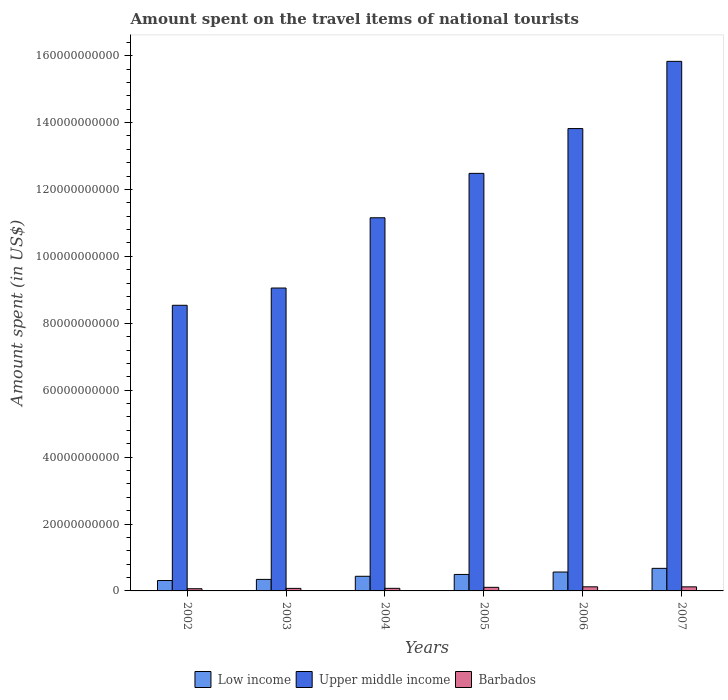How many different coloured bars are there?
Offer a very short reply. 3. Are the number of bars per tick equal to the number of legend labels?
Offer a terse response. Yes. How many bars are there on the 2nd tick from the right?
Offer a terse response. 3. In how many cases, is the number of bars for a given year not equal to the number of legend labels?
Give a very brief answer. 0. What is the amount spent on the travel items of national tourists in Upper middle income in 2005?
Keep it short and to the point. 1.25e+11. Across all years, what is the maximum amount spent on the travel items of national tourists in Upper middle income?
Provide a short and direct response. 1.58e+11. Across all years, what is the minimum amount spent on the travel items of national tourists in Upper middle income?
Your answer should be very brief. 8.54e+1. What is the total amount spent on the travel items of national tourists in Upper middle income in the graph?
Keep it short and to the point. 7.09e+11. What is the difference between the amount spent on the travel items of national tourists in Barbados in 2003 and that in 2006?
Keep it short and to the point. -4.70e+08. What is the difference between the amount spent on the travel items of national tourists in Barbados in 2003 and the amount spent on the travel items of national tourists in Low income in 2004?
Your answer should be very brief. -3.61e+09. What is the average amount spent on the travel items of national tourists in Barbados per year?
Offer a very short reply. 9.52e+08. In the year 2004, what is the difference between the amount spent on the travel items of national tourists in Barbados and amount spent on the travel items of national tourists in Upper middle income?
Your response must be concise. -1.11e+11. In how many years, is the amount spent on the travel items of national tourists in Upper middle income greater than 68000000000 US$?
Offer a terse response. 6. What is the ratio of the amount spent on the travel items of national tourists in Barbados in 2003 to that in 2007?
Keep it short and to the point. 0.62. What is the difference between the highest and the second highest amount spent on the travel items of national tourists in Barbados?
Your answer should be compact. 1.10e+07. What is the difference between the highest and the lowest amount spent on the travel items of national tourists in Low income?
Make the answer very short. 3.64e+09. Is the sum of the amount spent on the travel items of national tourists in Upper middle income in 2002 and 2004 greater than the maximum amount spent on the travel items of national tourists in Barbados across all years?
Offer a terse response. Yes. What does the 3rd bar from the left in 2005 represents?
Provide a succinct answer. Barbados. What does the 2nd bar from the right in 2002 represents?
Make the answer very short. Upper middle income. What is the difference between two consecutive major ticks on the Y-axis?
Keep it short and to the point. 2.00e+1. Does the graph contain any zero values?
Offer a terse response. No. Does the graph contain grids?
Provide a succinct answer. No. Where does the legend appear in the graph?
Give a very brief answer. Bottom center. What is the title of the graph?
Offer a terse response. Amount spent on the travel items of national tourists. What is the label or title of the Y-axis?
Give a very brief answer. Amount spent (in US$). What is the Amount spent (in US$) of Low income in 2002?
Ensure brevity in your answer.  3.11e+09. What is the Amount spent (in US$) in Upper middle income in 2002?
Provide a succinct answer. 8.54e+1. What is the Amount spent (in US$) of Barbados in 2002?
Your answer should be compact. 6.58e+08. What is the Amount spent (in US$) of Low income in 2003?
Keep it short and to the point. 3.45e+09. What is the Amount spent (in US$) in Upper middle income in 2003?
Ensure brevity in your answer.  9.05e+1. What is the Amount spent (in US$) of Barbados in 2003?
Provide a succinct answer. 7.58e+08. What is the Amount spent (in US$) in Low income in 2004?
Offer a very short reply. 4.37e+09. What is the Amount spent (in US$) in Upper middle income in 2004?
Provide a short and direct response. 1.12e+11. What is the Amount spent (in US$) of Barbados in 2004?
Offer a very short reply. 7.75e+08. What is the Amount spent (in US$) in Low income in 2005?
Your answer should be very brief. 4.93e+09. What is the Amount spent (in US$) of Upper middle income in 2005?
Ensure brevity in your answer.  1.25e+11. What is the Amount spent (in US$) in Barbados in 2005?
Your response must be concise. 1.07e+09. What is the Amount spent (in US$) in Low income in 2006?
Your response must be concise. 5.65e+09. What is the Amount spent (in US$) of Upper middle income in 2006?
Ensure brevity in your answer.  1.38e+11. What is the Amount spent (in US$) of Barbados in 2006?
Provide a succinct answer. 1.23e+09. What is the Amount spent (in US$) of Low income in 2007?
Give a very brief answer. 6.75e+09. What is the Amount spent (in US$) in Upper middle income in 2007?
Provide a short and direct response. 1.58e+11. What is the Amount spent (in US$) in Barbados in 2007?
Offer a very short reply. 1.22e+09. Across all years, what is the maximum Amount spent (in US$) in Low income?
Provide a short and direct response. 6.75e+09. Across all years, what is the maximum Amount spent (in US$) of Upper middle income?
Offer a very short reply. 1.58e+11. Across all years, what is the maximum Amount spent (in US$) of Barbados?
Keep it short and to the point. 1.23e+09. Across all years, what is the minimum Amount spent (in US$) in Low income?
Your response must be concise. 3.11e+09. Across all years, what is the minimum Amount spent (in US$) of Upper middle income?
Your response must be concise. 8.54e+1. Across all years, what is the minimum Amount spent (in US$) of Barbados?
Provide a succinct answer. 6.58e+08. What is the total Amount spent (in US$) of Low income in the graph?
Keep it short and to the point. 2.82e+1. What is the total Amount spent (in US$) in Upper middle income in the graph?
Your answer should be very brief. 7.09e+11. What is the total Amount spent (in US$) of Barbados in the graph?
Your answer should be compact. 5.71e+09. What is the difference between the Amount spent (in US$) of Low income in 2002 and that in 2003?
Your response must be concise. -3.36e+08. What is the difference between the Amount spent (in US$) of Upper middle income in 2002 and that in 2003?
Make the answer very short. -5.16e+09. What is the difference between the Amount spent (in US$) in Barbados in 2002 and that in 2003?
Give a very brief answer. -1.00e+08. What is the difference between the Amount spent (in US$) in Low income in 2002 and that in 2004?
Give a very brief answer. -1.26e+09. What is the difference between the Amount spent (in US$) of Upper middle income in 2002 and that in 2004?
Provide a short and direct response. -2.62e+1. What is the difference between the Amount spent (in US$) of Barbados in 2002 and that in 2004?
Offer a terse response. -1.17e+08. What is the difference between the Amount spent (in US$) of Low income in 2002 and that in 2005?
Provide a short and direct response. -1.82e+09. What is the difference between the Amount spent (in US$) of Upper middle income in 2002 and that in 2005?
Provide a short and direct response. -3.94e+1. What is the difference between the Amount spent (in US$) of Barbados in 2002 and that in 2005?
Give a very brief answer. -4.15e+08. What is the difference between the Amount spent (in US$) of Low income in 2002 and that in 2006?
Offer a very short reply. -2.54e+09. What is the difference between the Amount spent (in US$) in Upper middle income in 2002 and that in 2006?
Provide a succinct answer. -5.28e+1. What is the difference between the Amount spent (in US$) of Barbados in 2002 and that in 2006?
Make the answer very short. -5.70e+08. What is the difference between the Amount spent (in US$) in Low income in 2002 and that in 2007?
Your response must be concise. -3.64e+09. What is the difference between the Amount spent (in US$) of Upper middle income in 2002 and that in 2007?
Give a very brief answer. -7.29e+1. What is the difference between the Amount spent (in US$) of Barbados in 2002 and that in 2007?
Your answer should be very brief. -5.59e+08. What is the difference between the Amount spent (in US$) in Low income in 2003 and that in 2004?
Provide a succinct answer. -9.27e+08. What is the difference between the Amount spent (in US$) of Upper middle income in 2003 and that in 2004?
Make the answer very short. -2.10e+1. What is the difference between the Amount spent (in US$) in Barbados in 2003 and that in 2004?
Make the answer very short. -1.70e+07. What is the difference between the Amount spent (in US$) in Low income in 2003 and that in 2005?
Your answer should be compact. -1.48e+09. What is the difference between the Amount spent (in US$) in Upper middle income in 2003 and that in 2005?
Give a very brief answer. -3.43e+1. What is the difference between the Amount spent (in US$) of Barbados in 2003 and that in 2005?
Ensure brevity in your answer.  -3.15e+08. What is the difference between the Amount spent (in US$) in Low income in 2003 and that in 2006?
Your answer should be compact. -2.20e+09. What is the difference between the Amount spent (in US$) in Upper middle income in 2003 and that in 2006?
Provide a succinct answer. -4.77e+1. What is the difference between the Amount spent (in US$) of Barbados in 2003 and that in 2006?
Provide a succinct answer. -4.70e+08. What is the difference between the Amount spent (in US$) of Low income in 2003 and that in 2007?
Give a very brief answer. -3.30e+09. What is the difference between the Amount spent (in US$) in Upper middle income in 2003 and that in 2007?
Your answer should be compact. -6.78e+1. What is the difference between the Amount spent (in US$) in Barbados in 2003 and that in 2007?
Provide a short and direct response. -4.59e+08. What is the difference between the Amount spent (in US$) of Low income in 2004 and that in 2005?
Your answer should be very brief. -5.53e+08. What is the difference between the Amount spent (in US$) of Upper middle income in 2004 and that in 2005?
Make the answer very short. -1.33e+1. What is the difference between the Amount spent (in US$) of Barbados in 2004 and that in 2005?
Give a very brief answer. -2.98e+08. What is the difference between the Amount spent (in US$) of Low income in 2004 and that in 2006?
Keep it short and to the point. -1.28e+09. What is the difference between the Amount spent (in US$) in Upper middle income in 2004 and that in 2006?
Offer a terse response. -2.67e+1. What is the difference between the Amount spent (in US$) in Barbados in 2004 and that in 2006?
Keep it short and to the point. -4.53e+08. What is the difference between the Amount spent (in US$) of Low income in 2004 and that in 2007?
Provide a short and direct response. -2.37e+09. What is the difference between the Amount spent (in US$) of Upper middle income in 2004 and that in 2007?
Give a very brief answer. -4.68e+1. What is the difference between the Amount spent (in US$) in Barbados in 2004 and that in 2007?
Offer a very short reply. -4.42e+08. What is the difference between the Amount spent (in US$) of Low income in 2005 and that in 2006?
Give a very brief answer. -7.22e+08. What is the difference between the Amount spent (in US$) of Upper middle income in 2005 and that in 2006?
Keep it short and to the point. -1.34e+1. What is the difference between the Amount spent (in US$) in Barbados in 2005 and that in 2006?
Keep it short and to the point. -1.55e+08. What is the difference between the Amount spent (in US$) of Low income in 2005 and that in 2007?
Give a very brief answer. -1.82e+09. What is the difference between the Amount spent (in US$) of Upper middle income in 2005 and that in 2007?
Ensure brevity in your answer.  -3.35e+1. What is the difference between the Amount spent (in US$) of Barbados in 2005 and that in 2007?
Offer a terse response. -1.44e+08. What is the difference between the Amount spent (in US$) in Low income in 2006 and that in 2007?
Make the answer very short. -1.10e+09. What is the difference between the Amount spent (in US$) of Upper middle income in 2006 and that in 2007?
Give a very brief answer. -2.01e+1. What is the difference between the Amount spent (in US$) in Barbados in 2006 and that in 2007?
Make the answer very short. 1.10e+07. What is the difference between the Amount spent (in US$) in Low income in 2002 and the Amount spent (in US$) in Upper middle income in 2003?
Ensure brevity in your answer.  -8.74e+1. What is the difference between the Amount spent (in US$) of Low income in 2002 and the Amount spent (in US$) of Barbados in 2003?
Provide a succinct answer. 2.35e+09. What is the difference between the Amount spent (in US$) in Upper middle income in 2002 and the Amount spent (in US$) in Barbados in 2003?
Give a very brief answer. 8.46e+1. What is the difference between the Amount spent (in US$) in Low income in 2002 and the Amount spent (in US$) in Upper middle income in 2004?
Your answer should be very brief. -1.08e+11. What is the difference between the Amount spent (in US$) in Low income in 2002 and the Amount spent (in US$) in Barbados in 2004?
Your answer should be compact. 2.33e+09. What is the difference between the Amount spent (in US$) of Upper middle income in 2002 and the Amount spent (in US$) of Barbados in 2004?
Keep it short and to the point. 8.46e+1. What is the difference between the Amount spent (in US$) in Low income in 2002 and the Amount spent (in US$) in Upper middle income in 2005?
Ensure brevity in your answer.  -1.22e+11. What is the difference between the Amount spent (in US$) in Low income in 2002 and the Amount spent (in US$) in Barbados in 2005?
Keep it short and to the point. 2.04e+09. What is the difference between the Amount spent (in US$) of Upper middle income in 2002 and the Amount spent (in US$) of Barbados in 2005?
Offer a very short reply. 8.43e+1. What is the difference between the Amount spent (in US$) in Low income in 2002 and the Amount spent (in US$) in Upper middle income in 2006?
Ensure brevity in your answer.  -1.35e+11. What is the difference between the Amount spent (in US$) in Low income in 2002 and the Amount spent (in US$) in Barbados in 2006?
Provide a succinct answer. 1.88e+09. What is the difference between the Amount spent (in US$) of Upper middle income in 2002 and the Amount spent (in US$) of Barbados in 2006?
Make the answer very short. 8.42e+1. What is the difference between the Amount spent (in US$) of Low income in 2002 and the Amount spent (in US$) of Upper middle income in 2007?
Keep it short and to the point. -1.55e+11. What is the difference between the Amount spent (in US$) in Low income in 2002 and the Amount spent (in US$) in Barbados in 2007?
Your response must be concise. 1.89e+09. What is the difference between the Amount spent (in US$) of Upper middle income in 2002 and the Amount spent (in US$) of Barbados in 2007?
Give a very brief answer. 8.42e+1. What is the difference between the Amount spent (in US$) of Low income in 2003 and the Amount spent (in US$) of Upper middle income in 2004?
Make the answer very short. -1.08e+11. What is the difference between the Amount spent (in US$) in Low income in 2003 and the Amount spent (in US$) in Barbados in 2004?
Ensure brevity in your answer.  2.67e+09. What is the difference between the Amount spent (in US$) of Upper middle income in 2003 and the Amount spent (in US$) of Barbados in 2004?
Make the answer very short. 8.98e+1. What is the difference between the Amount spent (in US$) of Low income in 2003 and the Amount spent (in US$) of Upper middle income in 2005?
Offer a terse response. -1.21e+11. What is the difference between the Amount spent (in US$) in Low income in 2003 and the Amount spent (in US$) in Barbados in 2005?
Offer a very short reply. 2.37e+09. What is the difference between the Amount spent (in US$) of Upper middle income in 2003 and the Amount spent (in US$) of Barbados in 2005?
Offer a terse response. 8.95e+1. What is the difference between the Amount spent (in US$) in Low income in 2003 and the Amount spent (in US$) in Upper middle income in 2006?
Your answer should be very brief. -1.35e+11. What is the difference between the Amount spent (in US$) of Low income in 2003 and the Amount spent (in US$) of Barbados in 2006?
Offer a very short reply. 2.22e+09. What is the difference between the Amount spent (in US$) of Upper middle income in 2003 and the Amount spent (in US$) of Barbados in 2006?
Keep it short and to the point. 8.93e+1. What is the difference between the Amount spent (in US$) of Low income in 2003 and the Amount spent (in US$) of Upper middle income in 2007?
Your response must be concise. -1.55e+11. What is the difference between the Amount spent (in US$) in Low income in 2003 and the Amount spent (in US$) in Barbados in 2007?
Give a very brief answer. 2.23e+09. What is the difference between the Amount spent (in US$) in Upper middle income in 2003 and the Amount spent (in US$) in Barbados in 2007?
Your answer should be very brief. 8.93e+1. What is the difference between the Amount spent (in US$) of Low income in 2004 and the Amount spent (in US$) of Upper middle income in 2005?
Offer a terse response. -1.20e+11. What is the difference between the Amount spent (in US$) of Low income in 2004 and the Amount spent (in US$) of Barbados in 2005?
Offer a terse response. 3.30e+09. What is the difference between the Amount spent (in US$) in Upper middle income in 2004 and the Amount spent (in US$) in Barbados in 2005?
Make the answer very short. 1.10e+11. What is the difference between the Amount spent (in US$) of Low income in 2004 and the Amount spent (in US$) of Upper middle income in 2006?
Provide a short and direct response. -1.34e+11. What is the difference between the Amount spent (in US$) in Low income in 2004 and the Amount spent (in US$) in Barbados in 2006?
Make the answer very short. 3.14e+09. What is the difference between the Amount spent (in US$) in Upper middle income in 2004 and the Amount spent (in US$) in Barbados in 2006?
Ensure brevity in your answer.  1.10e+11. What is the difference between the Amount spent (in US$) of Low income in 2004 and the Amount spent (in US$) of Upper middle income in 2007?
Offer a very short reply. -1.54e+11. What is the difference between the Amount spent (in US$) in Low income in 2004 and the Amount spent (in US$) in Barbados in 2007?
Keep it short and to the point. 3.16e+09. What is the difference between the Amount spent (in US$) in Upper middle income in 2004 and the Amount spent (in US$) in Barbados in 2007?
Provide a short and direct response. 1.10e+11. What is the difference between the Amount spent (in US$) in Low income in 2005 and the Amount spent (in US$) in Upper middle income in 2006?
Make the answer very short. -1.33e+11. What is the difference between the Amount spent (in US$) in Low income in 2005 and the Amount spent (in US$) in Barbados in 2006?
Offer a very short reply. 3.70e+09. What is the difference between the Amount spent (in US$) in Upper middle income in 2005 and the Amount spent (in US$) in Barbados in 2006?
Provide a succinct answer. 1.24e+11. What is the difference between the Amount spent (in US$) of Low income in 2005 and the Amount spent (in US$) of Upper middle income in 2007?
Make the answer very short. -1.53e+11. What is the difference between the Amount spent (in US$) in Low income in 2005 and the Amount spent (in US$) in Barbados in 2007?
Give a very brief answer. 3.71e+09. What is the difference between the Amount spent (in US$) of Upper middle income in 2005 and the Amount spent (in US$) of Barbados in 2007?
Provide a short and direct response. 1.24e+11. What is the difference between the Amount spent (in US$) of Low income in 2006 and the Amount spent (in US$) of Upper middle income in 2007?
Make the answer very short. -1.53e+11. What is the difference between the Amount spent (in US$) in Low income in 2006 and the Amount spent (in US$) in Barbados in 2007?
Offer a terse response. 4.43e+09. What is the difference between the Amount spent (in US$) in Upper middle income in 2006 and the Amount spent (in US$) in Barbados in 2007?
Provide a short and direct response. 1.37e+11. What is the average Amount spent (in US$) in Low income per year?
Your answer should be very brief. 4.71e+09. What is the average Amount spent (in US$) in Upper middle income per year?
Give a very brief answer. 1.18e+11. What is the average Amount spent (in US$) of Barbados per year?
Keep it short and to the point. 9.52e+08. In the year 2002, what is the difference between the Amount spent (in US$) in Low income and Amount spent (in US$) in Upper middle income?
Give a very brief answer. -8.23e+1. In the year 2002, what is the difference between the Amount spent (in US$) in Low income and Amount spent (in US$) in Barbados?
Provide a short and direct response. 2.45e+09. In the year 2002, what is the difference between the Amount spent (in US$) of Upper middle income and Amount spent (in US$) of Barbados?
Your answer should be very brief. 8.47e+1. In the year 2003, what is the difference between the Amount spent (in US$) in Low income and Amount spent (in US$) in Upper middle income?
Your response must be concise. -8.71e+1. In the year 2003, what is the difference between the Amount spent (in US$) of Low income and Amount spent (in US$) of Barbados?
Keep it short and to the point. 2.69e+09. In the year 2003, what is the difference between the Amount spent (in US$) in Upper middle income and Amount spent (in US$) in Barbados?
Give a very brief answer. 8.98e+1. In the year 2004, what is the difference between the Amount spent (in US$) in Low income and Amount spent (in US$) in Upper middle income?
Offer a terse response. -1.07e+11. In the year 2004, what is the difference between the Amount spent (in US$) of Low income and Amount spent (in US$) of Barbados?
Provide a succinct answer. 3.60e+09. In the year 2004, what is the difference between the Amount spent (in US$) in Upper middle income and Amount spent (in US$) in Barbados?
Provide a short and direct response. 1.11e+11. In the year 2005, what is the difference between the Amount spent (in US$) in Low income and Amount spent (in US$) in Upper middle income?
Offer a very short reply. -1.20e+11. In the year 2005, what is the difference between the Amount spent (in US$) in Low income and Amount spent (in US$) in Barbados?
Your answer should be compact. 3.85e+09. In the year 2005, what is the difference between the Amount spent (in US$) of Upper middle income and Amount spent (in US$) of Barbados?
Your answer should be very brief. 1.24e+11. In the year 2006, what is the difference between the Amount spent (in US$) in Low income and Amount spent (in US$) in Upper middle income?
Offer a very short reply. -1.33e+11. In the year 2006, what is the difference between the Amount spent (in US$) of Low income and Amount spent (in US$) of Barbados?
Make the answer very short. 4.42e+09. In the year 2006, what is the difference between the Amount spent (in US$) in Upper middle income and Amount spent (in US$) in Barbados?
Your answer should be very brief. 1.37e+11. In the year 2007, what is the difference between the Amount spent (in US$) of Low income and Amount spent (in US$) of Upper middle income?
Keep it short and to the point. -1.52e+11. In the year 2007, what is the difference between the Amount spent (in US$) in Low income and Amount spent (in US$) in Barbados?
Ensure brevity in your answer.  5.53e+09. In the year 2007, what is the difference between the Amount spent (in US$) in Upper middle income and Amount spent (in US$) in Barbados?
Your answer should be compact. 1.57e+11. What is the ratio of the Amount spent (in US$) in Low income in 2002 to that in 2003?
Offer a very short reply. 0.9. What is the ratio of the Amount spent (in US$) of Upper middle income in 2002 to that in 2003?
Provide a short and direct response. 0.94. What is the ratio of the Amount spent (in US$) in Barbados in 2002 to that in 2003?
Keep it short and to the point. 0.87. What is the ratio of the Amount spent (in US$) of Low income in 2002 to that in 2004?
Provide a succinct answer. 0.71. What is the ratio of the Amount spent (in US$) in Upper middle income in 2002 to that in 2004?
Make the answer very short. 0.77. What is the ratio of the Amount spent (in US$) of Barbados in 2002 to that in 2004?
Ensure brevity in your answer.  0.85. What is the ratio of the Amount spent (in US$) in Low income in 2002 to that in 2005?
Your answer should be very brief. 0.63. What is the ratio of the Amount spent (in US$) of Upper middle income in 2002 to that in 2005?
Offer a very short reply. 0.68. What is the ratio of the Amount spent (in US$) of Barbados in 2002 to that in 2005?
Your response must be concise. 0.61. What is the ratio of the Amount spent (in US$) of Low income in 2002 to that in 2006?
Ensure brevity in your answer.  0.55. What is the ratio of the Amount spent (in US$) in Upper middle income in 2002 to that in 2006?
Your answer should be compact. 0.62. What is the ratio of the Amount spent (in US$) in Barbados in 2002 to that in 2006?
Your answer should be very brief. 0.54. What is the ratio of the Amount spent (in US$) of Low income in 2002 to that in 2007?
Ensure brevity in your answer.  0.46. What is the ratio of the Amount spent (in US$) of Upper middle income in 2002 to that in 2007?
Your answer should be very brief. 0.54. What is the ratio of the Amount spent (in US$) in Barbados in 2002 to that in 2007?
Your answer should be very brief. 0.54. What is the ratio of the Amount spent (in US$) of Low income in 2003 to that in 2004?
Provide a succinct answer. 0.79. What is the ratio of the Amount spent (in US$) in Upper middle income in 2003 to that in 2004?
Your answer should be very brief. 0.81. What is the ratio of the Amount spent (in US$) in Barbados in 2003 to that in 2004?
Provide a short and direct response. 0.98. What is the ratio of the Amount spent (in US$) in Low income in 2003 to that in 2005?
Offer a very short reply. 0.7. What is the ratio of the Amount spent (in US$) in Upper middle income in 2003 to that in 2005?
Your answer should be compact. 0.73. What is the ratio of the Amount spent (in US$) of Barbados in 2003 to that in 2005?
Offer a terse response. 0.71. What is the ratio of the Amount spent (in US$) of Low income in 2003 to that in 2006?
Provide a succinct answer. 0.61. What is the ratio of the Amount spent (in US$) of Upper middle income in 2003 to that in 2006?
Your answer should be very brief. 0.66. What is the ratio of the Amount spent (in US$) in Barbados in 2003 to that in 2006?
Your answer should be very brief. 0.62. What is the ratio of the Amount spent (in US$) of Low income in 2003 to that in 2007?
Keep it short and to the point. 0.51. What is the ratio of the Amount spent (in US$) of Upper middle income in 2003 to that in 2007?
Your answer should be very brief. 0.57. What is the ratio of the Amount spent (in US$) of Barbados in 2003 to that in 2007?
Your response must be concise. 0.62. What is the ratio of the Amount spent (in US$) of Low income in 2004 to that in 2005?
Your answer should be very brief. 0.89. What is the ratio of the Amount spent (in US$) in Upper middle income in 2004 to that in 2005?
Ensure brevity in your answer.  0.89. What is the ratio of the Amount spent (in US$) of Barbados in 2004 to that in 2005?
Your answer should be very brief. 0.72. What is the ratio of the Amount spent (in US$) of Low income in 2004 to that in 2006?
Your response must be concise. 0.77. What is the ratio of the Amount spent (in US$) in Upper middle income in 2004 to that in 2006?
Offer a very short reply. 0.81. What is the ratio of the Amount spent (in US$) of Barbados in 2004 to that in 2006?
Offer a terse response. 0.63. What is the ratio of the Amount spent (in US$) of Low income in 2004 to that in 2007?
Your answer should be compact. 0.65. What is the ratio of the Amount spent (in US$) in Upper middle income in 2004 to that in 2007?
Offer a terse response. 0.7. What is the ratio of the Amount spent (in US$) of Barbados in 2004 to that in 2007?
Ensure brevity in your answer.  0.64. What is the ratio of the Amount spent (in US$) of Low income in 2005 to that in 2006?
Make the answer very short. 0.87. What is the ratio of the Amount spent (in US$) of Upper middle income in 2005 to that in 2006?
Offer a very short reply. 0.9. What is the ratio of the Amount spent (in US$) of Barbados in 2005 to that in 2006?
Make the answer very short. 0.87. What is the ratio of the Amount spent (in US$) of Low income in 2005 to that in 2007?
Offer a very short reply. 0.73. What is the ratio of the Amount spent (in US$) of Upper middle income in 2005 to that in 2007?
Your response must be concise. 0.79. What is the ratio of the Amount spent (in US$) of Barbados in 2005 to that in 2007?
Ensure brevity in your answer.  0.88. What is the ratio of the Amount spent (in US$) in Low income in 2006 to that in 2007?
Ensure brevity in your answer.  0.84. What is the ratio of the Amount spent (in US$) of Upper middle income in 2006 to that in 2007?
Offer a very short reply. 0.87. What is the difference between the highest and the second highest Amount spent (in US$) of Low income?
Your response must be concise. 1.10e+09. What is the difference between the highest and the second highest Amount spent (in US$) in Upper middle income?
Offer a terse response. 2.01e+1. What is the difference between the highest and the second highest Amount spent (in US$) in Barbados?
Make the answer very short. 1.10e+07. What is the difference between the highest and the lowest Amount spent (in US$) of Low income?
Ensure brevity in your answer.  3.64e+09. What is the difference between the highest and the lowest Amount spent (in US$) of Upper middle income?
Provide a succinct answer. 7.29e+1. What is the difference between the highest and the lowest Amount spent (in US$) in Barbados?
Your answer should be very brief. 5.70e+08. 